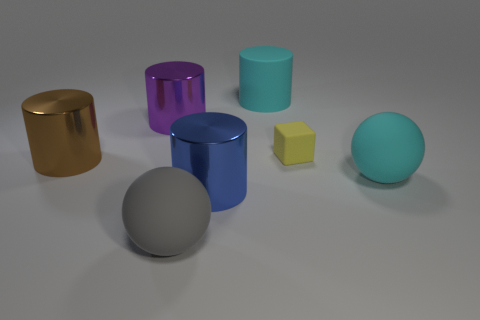Add 1 yellow metallic blocks. How many objects exist? 8 Subtract all red cylinders. Subtract all brown cubes. How many cylinders are left? 4 Subtract all cylinders. How many objects are left? 3 Subtract all purple things. Subtract all cyan spheres. How many objects are left? 5 Add 3 large objects. How many large objects are left? 9 Add 2 rubber cylinders. How many rubber cylinders exist? 3 Subtract 0 purple spheres. How many objects are left? 7 